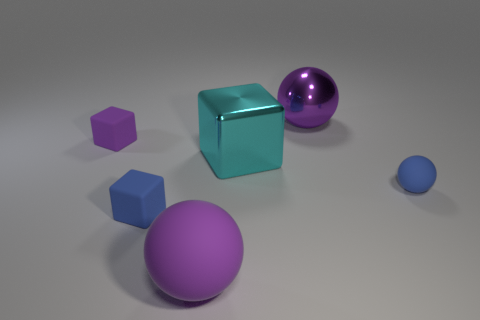How many objects are metal objects or big things behind the purple block?
Make the answer very short. 2. There is a thing that is both behind the big shiny block and on the right side of the cyan block; what is it made of?
Provide a succinct answer. Metal. There is a large sphere in front of the blue ball; what is it made of?
Offer a very short reply. Rubber. There is a large thing that is made of the same material as the small purple object; what color is it?
Offer a terse response. Purple. Is the shape of the big purple rubber thing the same as the tiny blue rubber thing that is right of the purple shiny sphere?
Provide a succinct answer. Yes. Are there any large metallic spheres in front of the large purple matte object?
Keep it short and to the point. No. What is the material of the other big object that is the same color as the large matte thing?
Offer a terse response. Metal. There is a blue block; is its size the same as the ball that is in front of the small blue ball?
Your answer should be compact. No. Are there any things that have the same color as the shiny sphere?
Keep it short and to the point. Yes. Is there a blue thing of the same shape as the small purple rubber thing?
Ensure brevity in your answer.  Yes. 